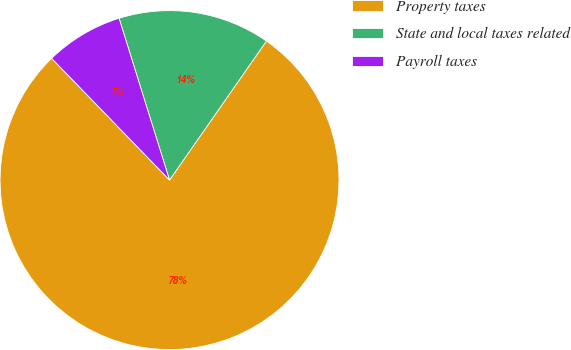<chart> <loc_0><loc_0><loc_500><loc_500><pie_chart><fcel>Property taxes<fcel>State and local taxes related<fcel>Payroll taxes<nl><fcel>78.07%<fcel>14.5%<fcel>7.43%<nl></chart> 